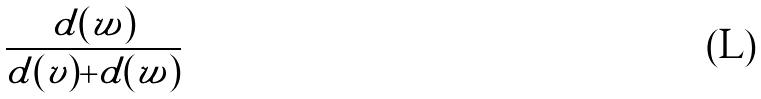<formula> <loc_0><loc_0><loc_500><loc_500>\frac { d ( w ) } { d ( v ) + d ( w ) }</formula> 